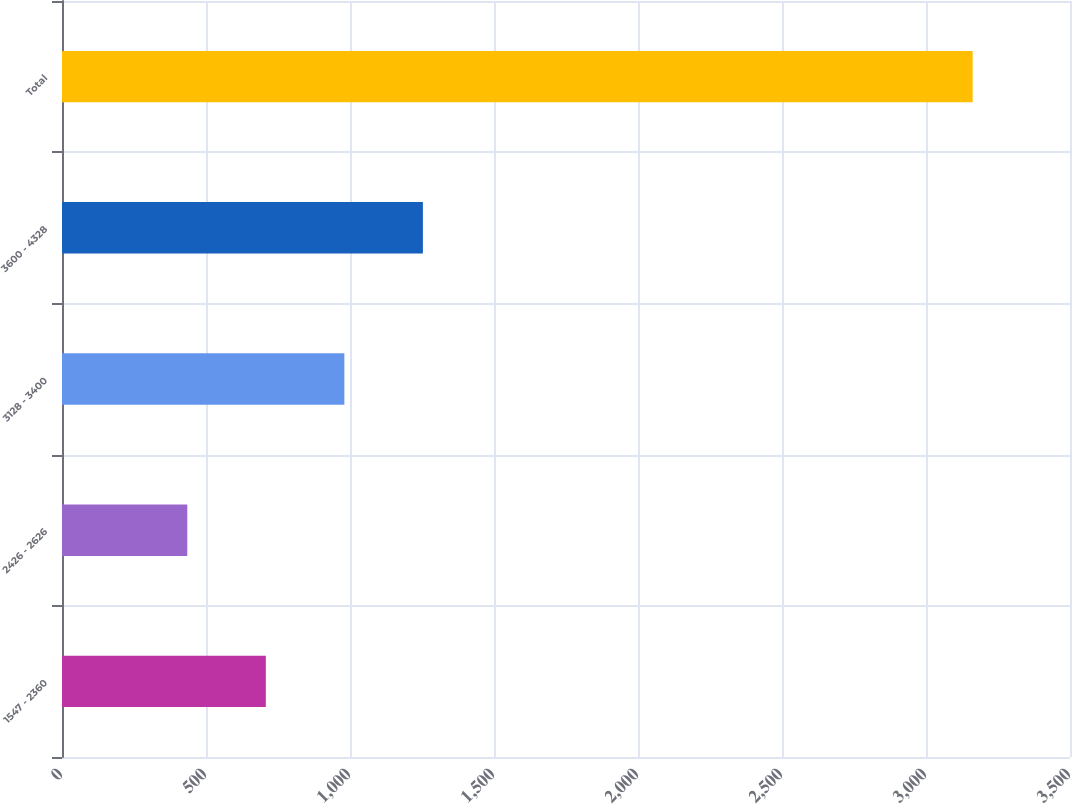Convert chart. <chart><loc_0><loc_0><loc_500><loc_500><bar_chart><fcel>1547 - 2360<fcel>2426 - 2626<fcel>3128 - 3400<fcel>3600 - 4328<fcel>Total<nl><fcel>707.7<fcel>435<fcel>980.4<fcel>1253.1<fcel>3162<nl></chart> 